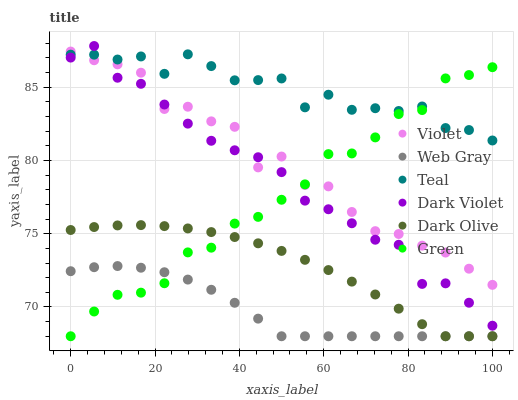Does Web Gray have the minimum area under the curve?
Answer yes or no. Yes. Does Teal have the maximum area under the curve?
Answer yes or no. Yes. Does Dark Olive have the minimum area under the curve?
Answer yes or no. No. Does Dark Olive have the maximum area under the curve?
Answer yes or no. No. Is Dark Olive the smoothest?
Answer yes or no. Yes. Is Violet the roughest?
Answer yes or no. Yes. Is Dark Violet the smoothest?
Answer yes or no. No. Is Dark Violet the roughest?
Answer yes or no. No. Does Web Gray have the lowest value?
Answer yes or no. Yes. Does Dark Violet have the lowest value?
Answer yes or no. No. Does Dark Violet have the highest value?
Answer yes or no. Yes. Does Dark Olive have the highest value?
Answer yes or no. No. Is Dark Olive less than Teal?
Answer yes or no. Yes. Is Dark Violet greater than Dark Olive?
Answer yes or no. Yes. Does Green intersect Teal?
Answer yes or no. Yes. Is Green less than Teal?
Answer yes or no. No. Is Green greater than Teal?
Answer yes or no. No. Does Dark Olive intersect Teal?
Answer yes or no. No. 